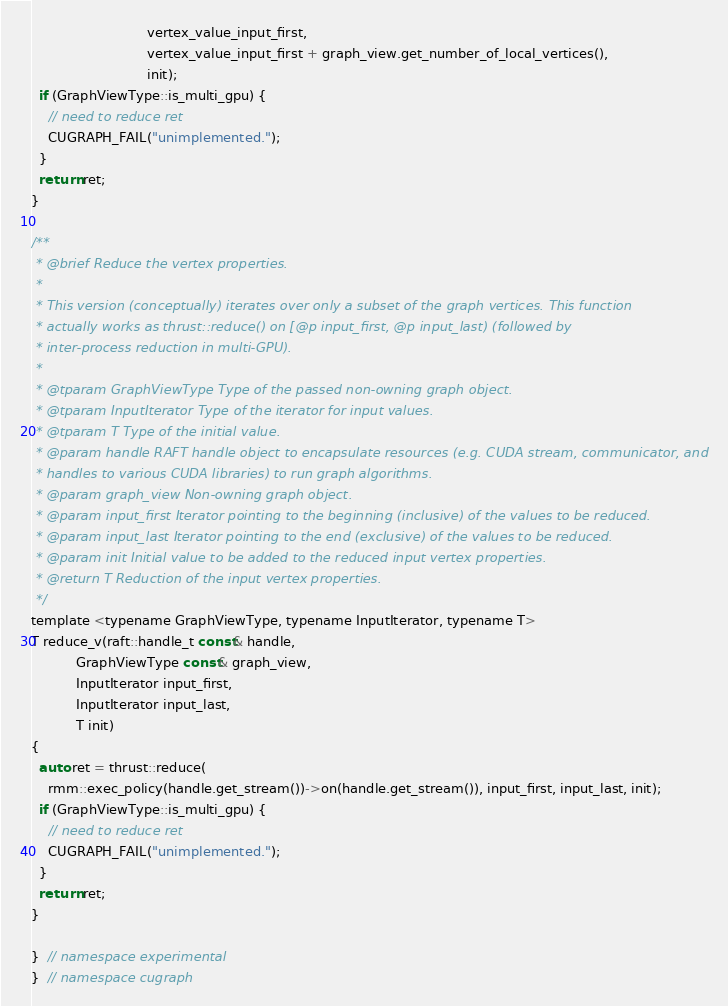<code> <loc_0><loc_0><loc_500><loc_500><_Cuda_>                            vertex_value_input_first,
                            vertex_value_input_first + graph_view.get_number_of_local_vertices(),
                            init);
  if (GraphViewType::is_multi_gpu) {
    // need to reduce ret
    CUGRAPH_FAIL("unimplemented.");
  }
  return ret;
}

/**
 * @brief Reduce the vertex properties.
 *
 * This version (conceptually) iterates over only a subset of the graph vertices. This function
 * actually works as thrust::reduce() on [@p input_first, @p input_last) (followed by
 * inter-process reduction in multi-GPU).
 *
 * @tparam GraphViewType Type of the passed non-owning graph object.
 * @tparam InputIterator Type of the iterator for input values.
 * @tparam T Type of the initial value.
 * @param handle RAFT handle object to encapsulate resources (e.g. CUDA stream, communicator, and
 * handles to various CUDA libraries) to run graph algorithms.
 * @param graph_view Non-owning graph object.
 * @param input_first Iterator pointing to the beginning (inclusive) of the values to be reduced.
 * @param input_last Iterator pointing to the end (exclusive) of the values to be reduced.
 * @param init Initial value to be added to the reduced input vertex properties.
 * @return T Reduction of the input vertex properties.
 */
template <typename GraphViewType, typename InputIterator, typename T>
T reduce_v(raft::handle_t const& handle,
           GraphViewType const& graph_view,
           InputIterator input_first,
           InputIterator input_last,
           T init)
{
  auto ret = thrust::reduce(
    rmm::exec_policy(handle.get_stream())->on(handle.get_stream()), input_first, input_last, init);
  if (GraphViewType::is_multi_gpu) {
    // need to reduce ret
    CUGRAPH_FAIL("unimplemented.");
  }
  return ret;
}

}  // namespace experimental
}  // namespace cugraph
</code> 